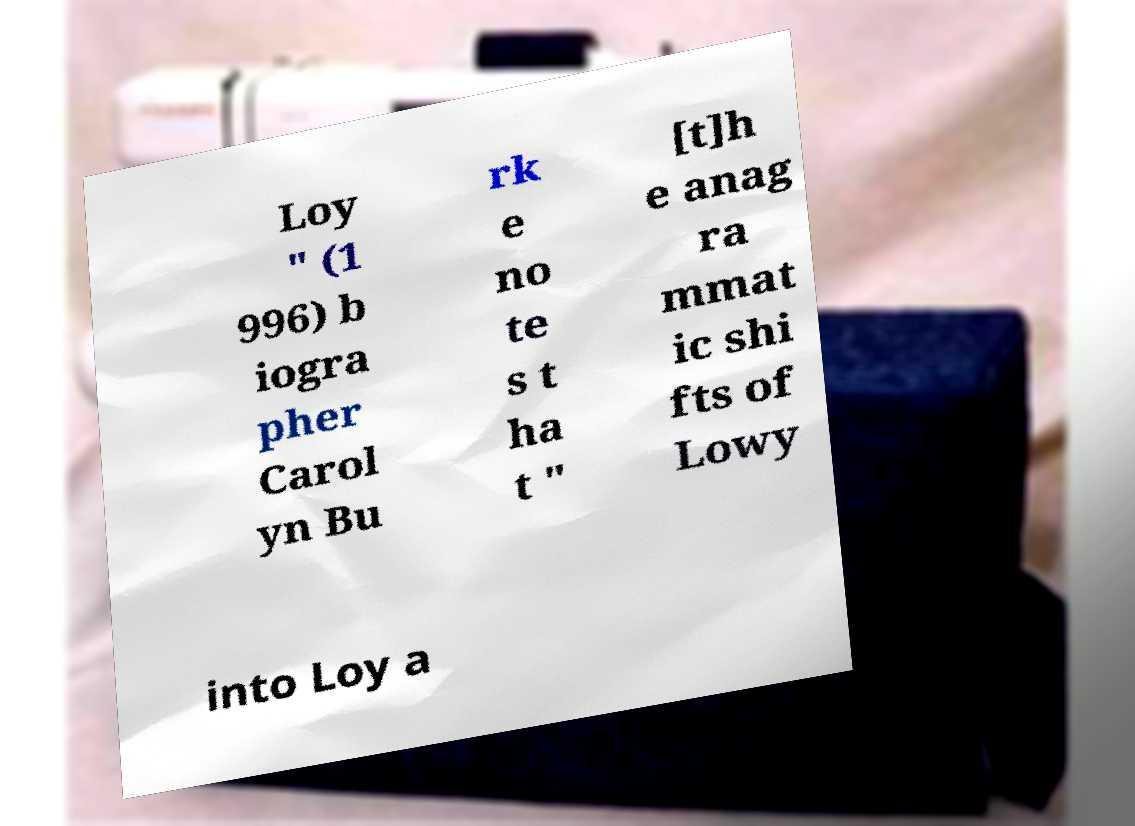Could you assist in decoding the text presented in this image and type it out clearly? Loy " (1 996) b iogra pher Carol yn Bu rk e no te s t ha t " [t]h e anag ra mmat ic shi fts of Lowy into Loy a 